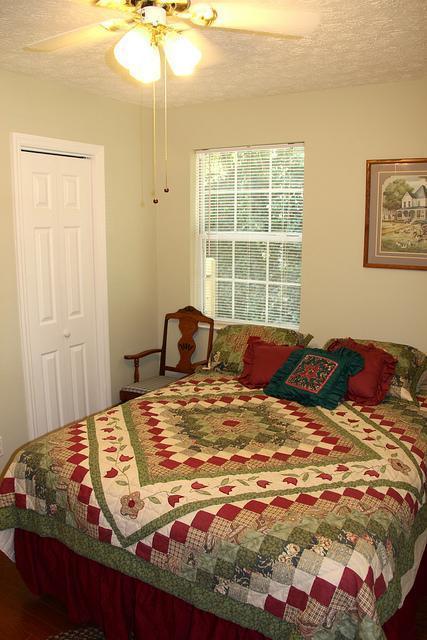How many cushions are on the bed?
Give a very brief answer. 5. How many beds can be seen?
Give a very brief answer. 1. How many cows are facing the camera?
Give a very brief answer. 0. 